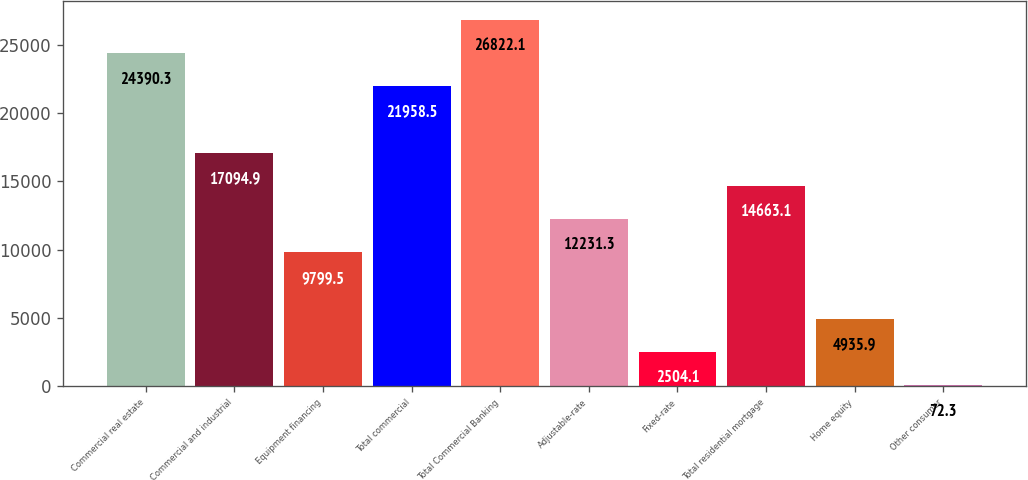Convert chart. <chart><loc_0><loc_0><loc_500><loc_500><bar_chart><fcel>Commercial real estate<fcel>Commercial and industrial<fcel>Equipment financing<fcel>Total commercial<fcel>Total Commercial Banking<fcel>Adjustable-rate<fcel>Fixed-rate<fcel>Total residential mortgage<fcel>Home equity<fcel>Other consumer<nl><fcel>24390.3<fcel>17094.9<fcel>9799.5<fcel>21958.5<fcel>26822.1<fcel>12231.3<fcel>2504.1<fcel>14663.1<fcel>4935.9<fcel>72.3<nl></chart> 